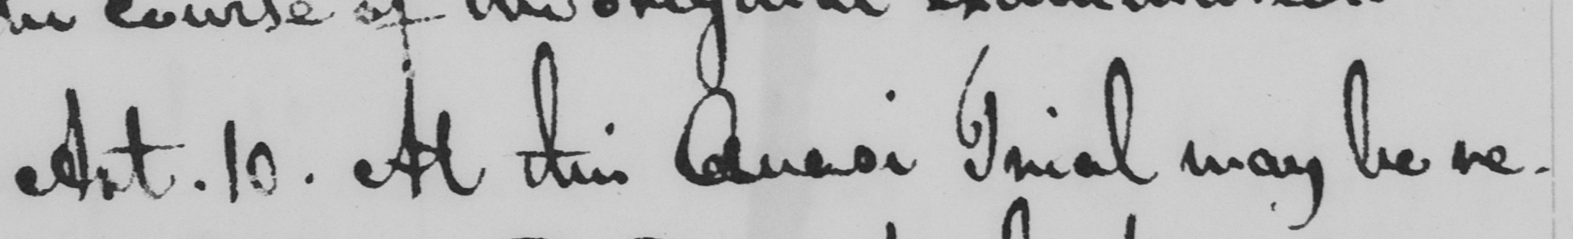Please provide the text content of this handwritten line. Art. 10. At this Quasi Trial may be re- 